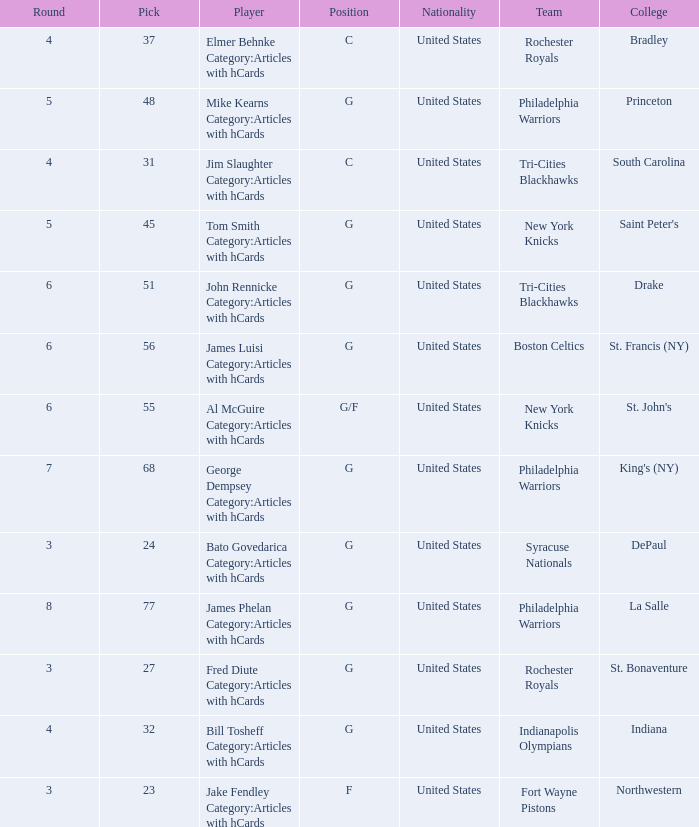What is the sum total of picks for drake players from the tri-cities blackhawks? 51.0. 